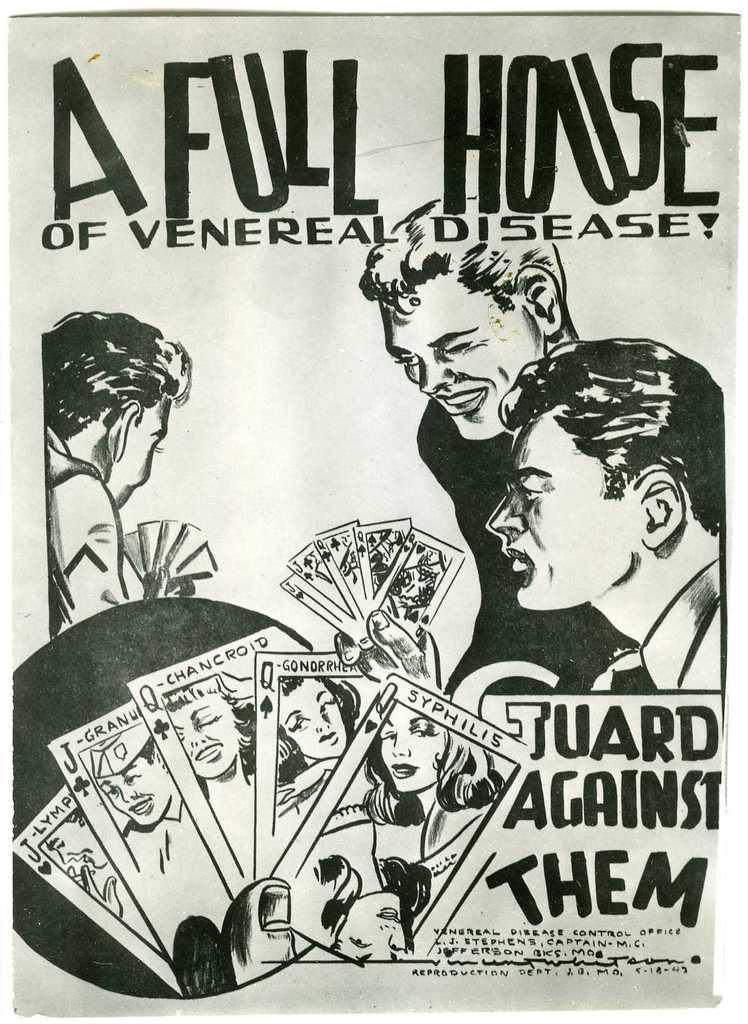What is the main subject of the image? The main subject of the image is a picture of persons. What else can be seen in the image besides the picture of persons? There is text on a paper in the image. How many cows are visible in the image? There are no cows present in the image. What is the size of the celery in the image? There is no celery present in the image. 